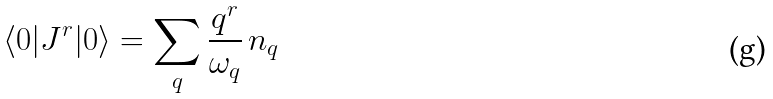<formula> <loc_0><loc_0><loc_500><loc_500>\langle 0 | J ^ { r } | 0 \rangle = \sum _ { q } \frac { q ^ { r } } { \omega _ { q } } \, n _ { q }</formula> 